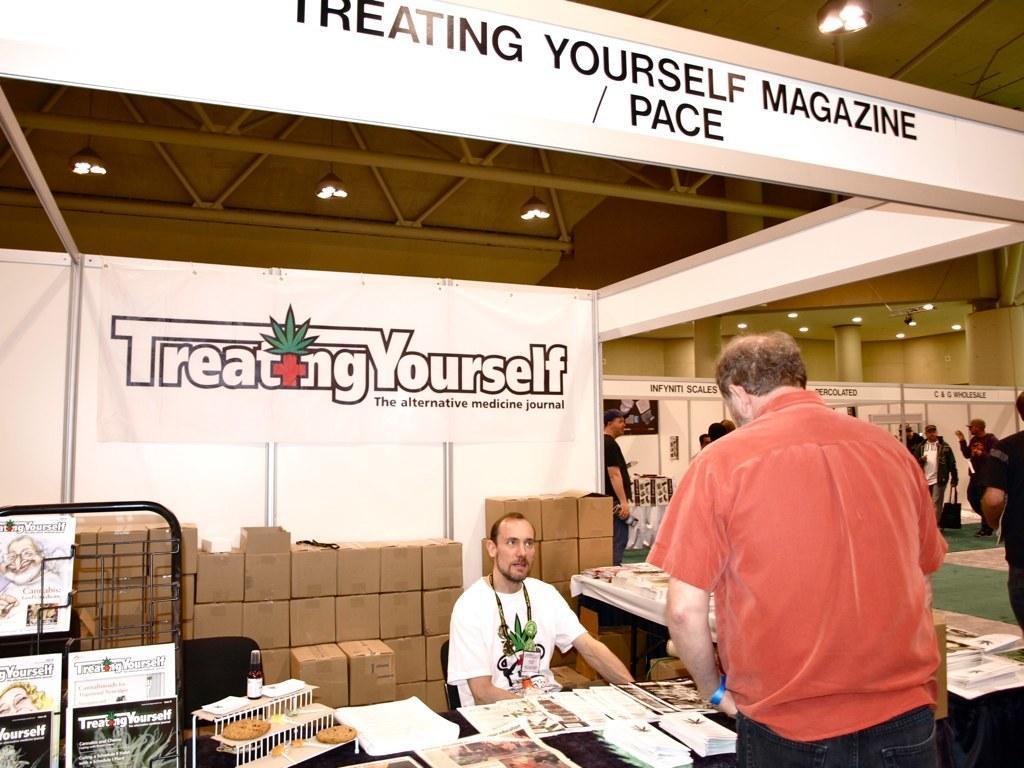Describe this image in one or two sentences. In this picture there are two people one is sitting on the chair in front of the table and other is standing before the table, there is treating yourself poster above the area of the image and boxes of stock behind the man at the left side of the image and there are other people those who are walking in the are at the right side of the image. 